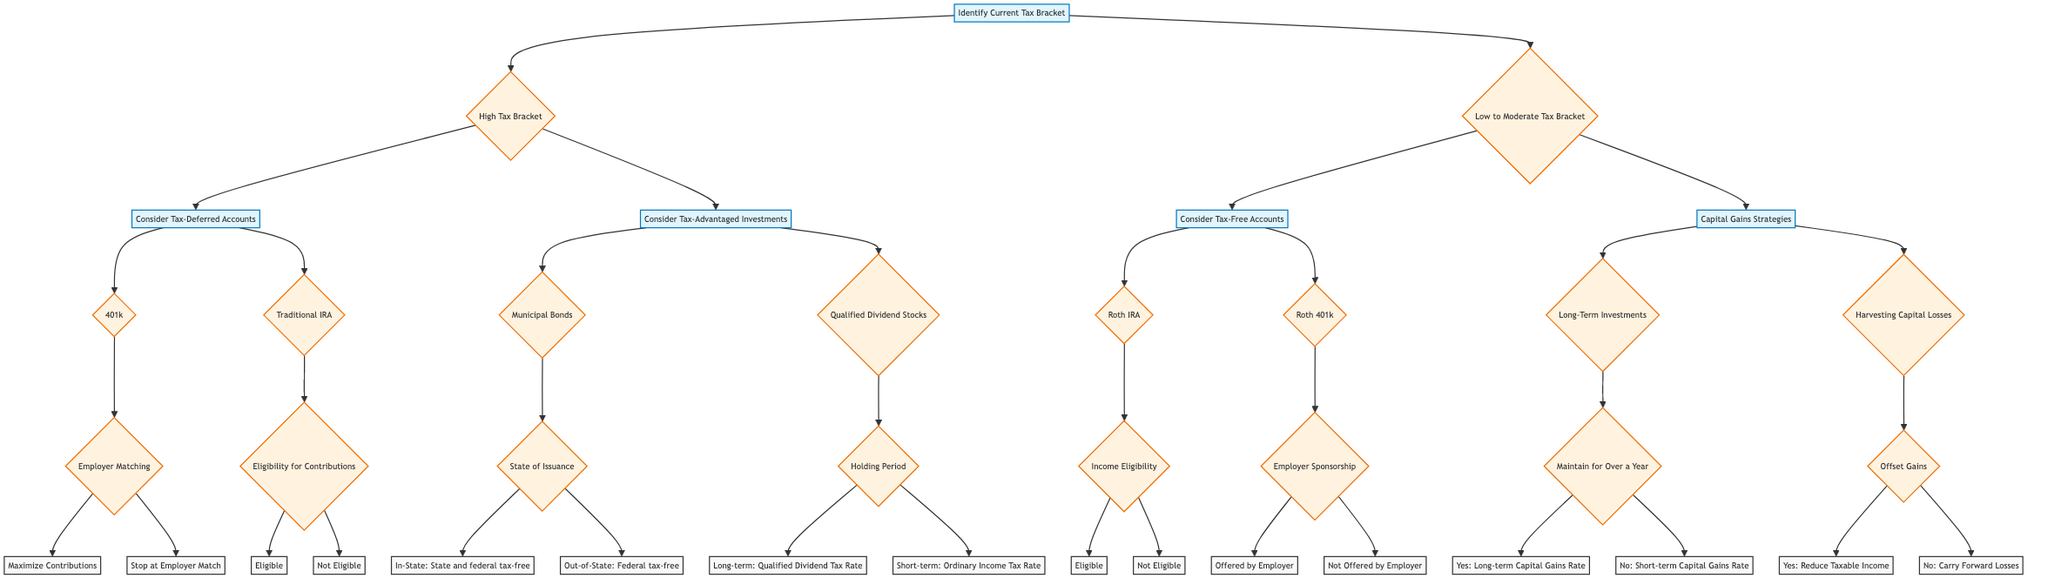What are the main categories of investment options in the diagram? The diagram presents two main categories based on tax brackets: "High Tax Bracket" and "Low to Moderate Tax Bracket."
Answer: High Tax Bracket, Low to Moderate Tax Bracket What types of accounts are suggested for high tax bracket individuals? The suggested types of accounts for high tax bracket individuals are "Tax-Deferred Accounts" and "Tax-Advantaged Investments."
Answer: Tax-Deferred Accounts, Tax-Advantaged Investments What investment option is available under "Consider Tax-Free Accounts"? Within "Consider Tax-Free Accounts," the investment option available is "Roth IRA" and "Roth 401(k)."
Answer: Roth IRA, Roth 401(k) For the option "Municipal Bonds," what are the tax benefits for bonds issued in-state? The tax benefit for bonds issued in-state is that they are "State and federal tax-free."
Answer: State and federal tax-free If an individual is eligible for contributions, which account can they consider under "Traditional IRA"? If an individual is eligible for contributions, they can consider the "Traditional IRA" under the category "Tax-Deferred Accounts."
Answer: Traditional IRA In the "High Tax Bracket" category, how many sub-decisions are there under "Consider Tax-Deferred Accounts"? There are two sub-decisions under "Consider Tax-Deferred Accounts": 401(k) and Traditional IRA.
Answer: 2 What tax rate applies to long-term qualified dividend stocks? The tax rate that applies to long-term qualified dividend stocks is the "Qualified Dividend Tax Rate."
Answer: Qualified Dividend Tax Rate In the "Low to Moderate Tax Bracket" category, what is a strategy for minimizing capital gains tax? A strategy for minimizing capital gains tax is "Harvesting Capital Losses."
Answer: Harvesting Capital Losses What occurs if an individual does not maintain their investment for over a year? If an individual does not maintain their investment for over a year, they will be subject to the "Short-term Capital Gains Rate."
Answer: Short-term Capital Gains Rate 